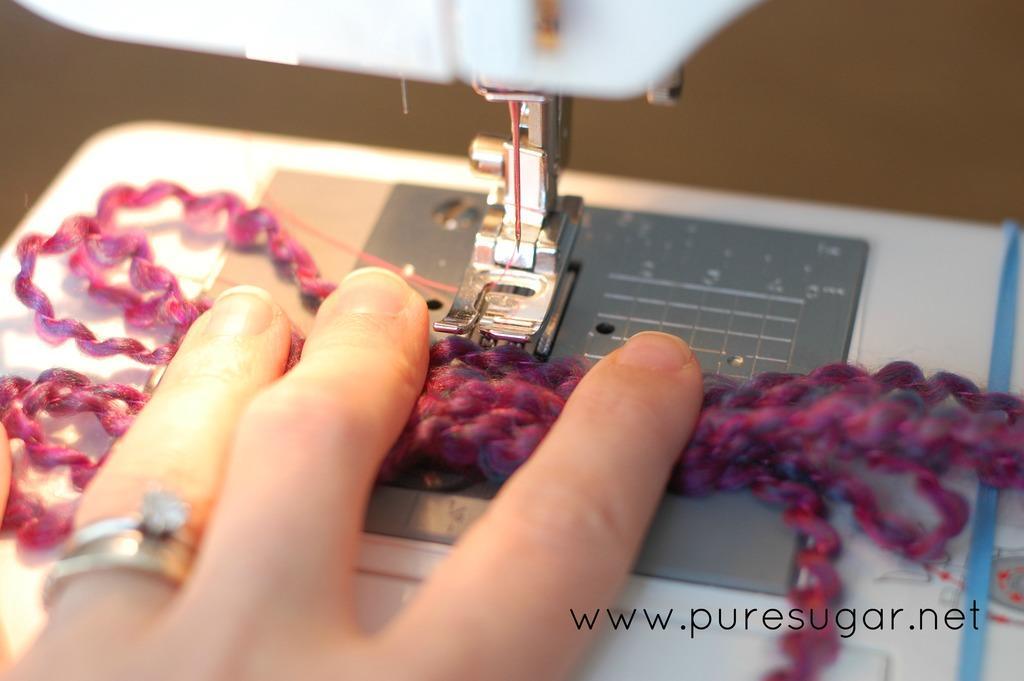In one or two sentences, can you explain what this image depicts? In this picture, we can see person hand, an object, stitching machine, and we can see some text in the bottom right corner of the picture. 